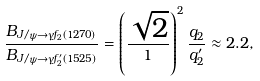Convert formula to latex. <formula><loc_0><loc_0><loc_500><loc_500>\frac { B _ { J / \psi \rightarrow \gamma f _ { 2 } ( 1 2 7 0 ) } } { B _ { J / \psi \rightarrow \gamma f ^ { \prime } _ { 2 } ( 1 5 2 5 ) } } = \left ( \frac { \sqrt { 2 } } { 1 } \right ) ^ { 2 } \frac { q _ { 2 } } { q ^ { \prime } _ { 2 } } \approx 2 . 2 ,</formula> 